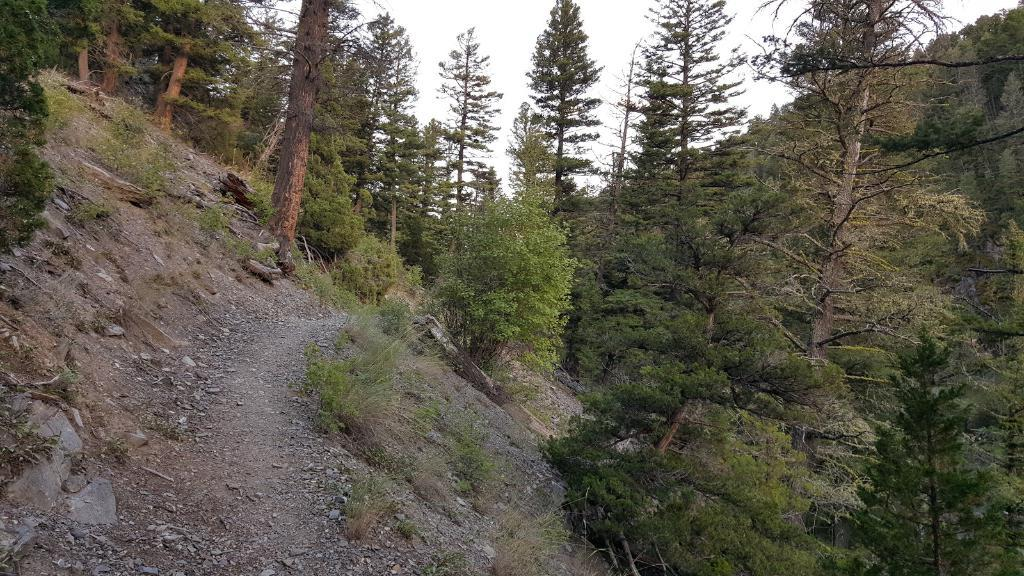What type of vegetation is present in the image? There are trees in the image. What else can be seen on the ground in the image? There is grass and stones visible in the image. What is visible at the top of the image? The sky is visible at the top of the image. What type of humor can be seen in the image? There is no humor present in the image; it features trees, grass, stones, and the sky. How many mice are visible in the image? There are no mice present in the image. 